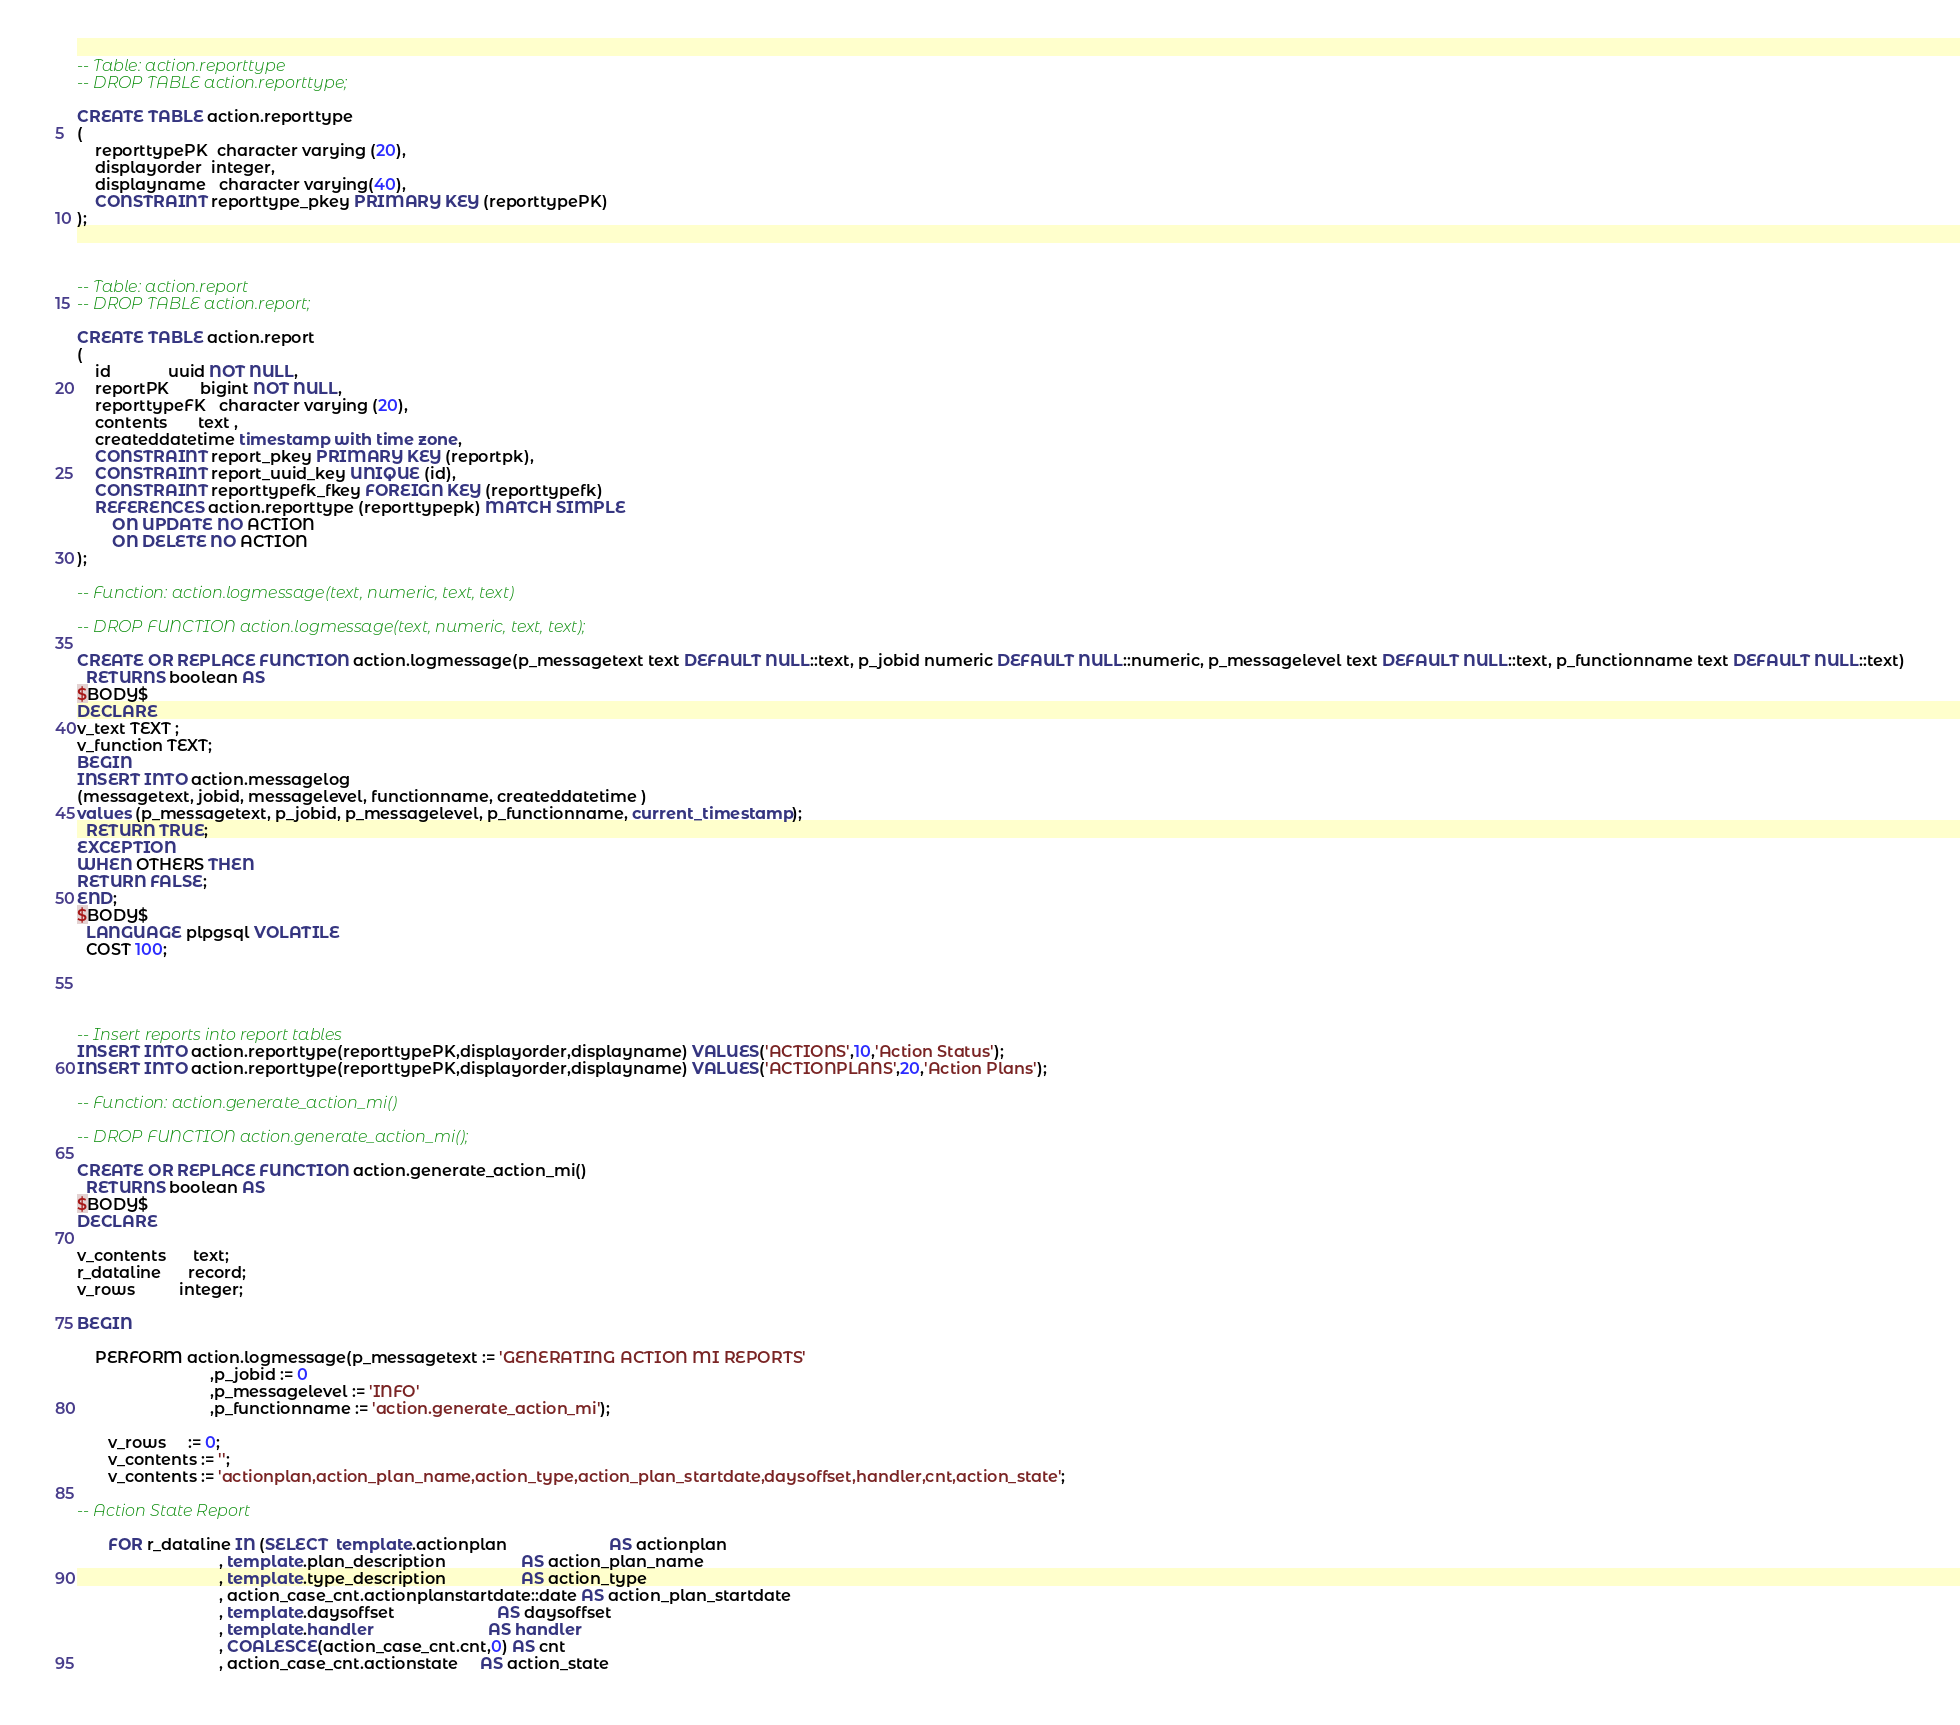Convert code to text. <code><loc_0><loc_0><loc_500><loc_500><_SQL_>

-- Table: action.reporttype
-- DROP TABLE action.reporttype;

CREATE TABLE action.reporttype
(
    reporttypePK  character varying (20),
    displayorder  integer,
    displayname   character varying(40),
    CONSTRAINT reporttype_pkey PRIMARY KEY (reporttypePK)
);



-- Table: action.report
-- DROP TABLE action.report;

CREATE TABLE action.report
(
    id             uuid NOT NULL,
    reportPK       bigint NOT NULL,
    reporttypeFK   character varying (20),
    contents       text ,
    createddatetime timestamp with time zone,
    CONSTRAINT report_pkey PRIMARY KEY (reportpk),
    CONSTRAINT report_uuid_key UNIQUE (id),
    CONSTRAINT reporttypefk_fkey FOREIGN KEY (reporttypefk)
    REFERENCES action.reporttype (reporttypepk) MATCH SIMPLE
        ON UPDATE NO ACTION
        ON DELETE NO ACTION
);

-- Function: action.logmessage(text, numeric, text, text)

-- DROP FUNCTION action.logmessage(text, numeric, text, text);

CREATE OR REPLACE FUNCTION action.logmessage(p_messagetext text DEFAULT NULL::text, p_jobid numeric DEFAULT NULL::numeric, p_messagelevel text DEFAULT NULL::text, p_functionname text DEFAULT NULL::text)
  RETURNS boolean AS
$BODY$
DECLARE
v_text TEXT ;
v_function TEXT;
BEGIN
INSERT INTO action.messagelog
(messagetext, jobid, messagelevel, functionname, createddatetime )
values (p_messagetext, p_jobid, p_messagelevel, p_functionname, current_timestamp);
  RETURN TRUE;
EXCEPTION
WHEN OTHERS THEN
RETURN FALSE;
END;
$BODY$
  LANGUAGE plpgsql VOLATILE
  COST 100;




-- Insert reports into report tables 
INSERT INTO action.reporttype(reporttypePK,displayorder,displayname) VALUES('ACTIONS',10,'Action Status');
INSERT INTO action.reporttype(reporttypePK,displayorder,displayname) VALUES('ACTIONPLANS',20,'Action Plans');

-- Function: action.generate_action_mi()

-- DROP FUNCTION action.generate_action_mi();

CREATE OR REPLACE FUNCTION action.generate_action_mi()
  RETURNS boolean AS
$BODY$
DECLARE

v_contents      text;
r_dataline      record;
v_rows          integer;

BEGIN
    
    PERFORM action.logmessage(p_messagetext := 'GENERATING ACTION MI REPORTS'
                              ,p_jobid := 0
                              ,p_messagelevel := 'INFO'
                              ,p_functionname := 'action.generate_action_mi');  
    
       v_rows     := 0;
       v_contents := '';
       v_contents := 'actionplan,action_plan_name,action_type,action_plan_startdate,daysoffset,handler,cnt,action_state';

-- Action State Report

       FOR r_dataline IN (SELECT  template.actionplan                       AS actionplan
                                , template.plan_description                 AS action_plan_name
                                , template.type_description                 AS action_type
                                , action_case_cnt.actionplanstartdate::date AS action_plan_startdate      
                                , template.daysoffset                       AS daysoffset
                                , template.handler                          AS handler
                                , COALESCE(action_case_cnt.cnt,0) AS cnt
                                , action_case_cnt.actionstate     AS action_state     </code> 